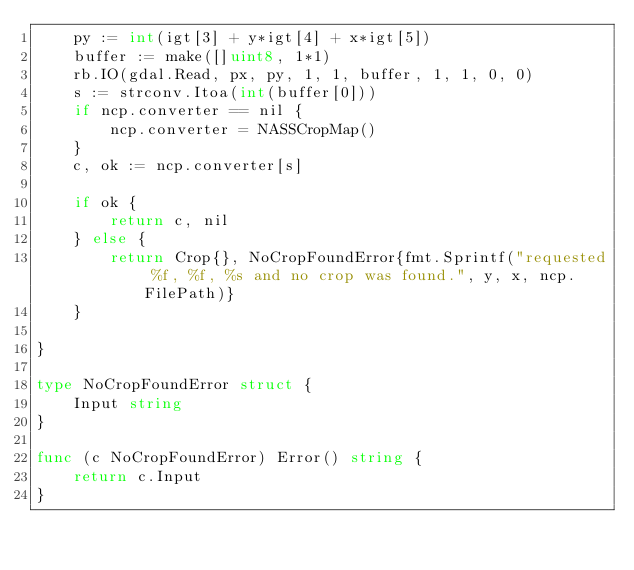Convert code to text. <code><loc_0><loc_0><loc_500><loc_500><_Go_>	py := int(igt[3] + y*igt[4] + x*igt[5])
	buffer := make([]uint8, 1*1)
	rb.IO(gdal.Read, px, py, 1, 1, buffer, 1, 1, 0, 0)
	s := strconv.Itoa(int(buffer[0]))
	if ncp.converter == nil {
		ncp.converter = NASSCropMap()
	}
	c, ok := ncp.converter[s]

	if ok {
		return c, nil
	} else {
		return Crop{}, NoCropFoundError{fmt.Sprintf("requested %f, %f, %s and no crop was found.", y, x, ncp.FilePath)}
	}

}

type NoCropFoundError struct {
	Input string
}

func (c NoCropFoundError) Error() string {
	return c.Input
}
</code> 